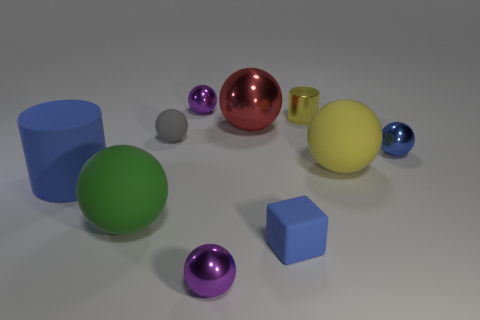There is a blue thing that is to the left of the tiny blue metal object and behind the tiny blue cube; what is its size?
Offer a terse response. Large. What material is the small sphere that is the same color as the big cylinder?
Your answer should be compact. Metal. Are there any blue metallic objects of the same size as the gray matte sphere?
Your answer should be very brief. Yes. What is the color of the ball behind the big red thing?
Your response must be concise. Purple. Are there any big red objects that are behind the tiny metallic ball behind the tiny rubber ball?
Provide a succinct answer. No. What number of other things are there of the same color as the matte cylinder?
Your answer should be compact. 2. Do the shiny sphere in front of the blue rubber cylinder and the ball that is right of the yellow rubber object have the same size?
Offer a terse response. Yes. There is a cylinder that is to the left of the purple shiny ball that is in front of the big green ball; how big is it?
Your response must be concise. Large. There is a blue thing that is on the right side of the large green ball and behind the small rubber block; what material is it made of?
Your answer should be compact. Metal. The large shiny object has what color?
Make the answer very short. Red. 